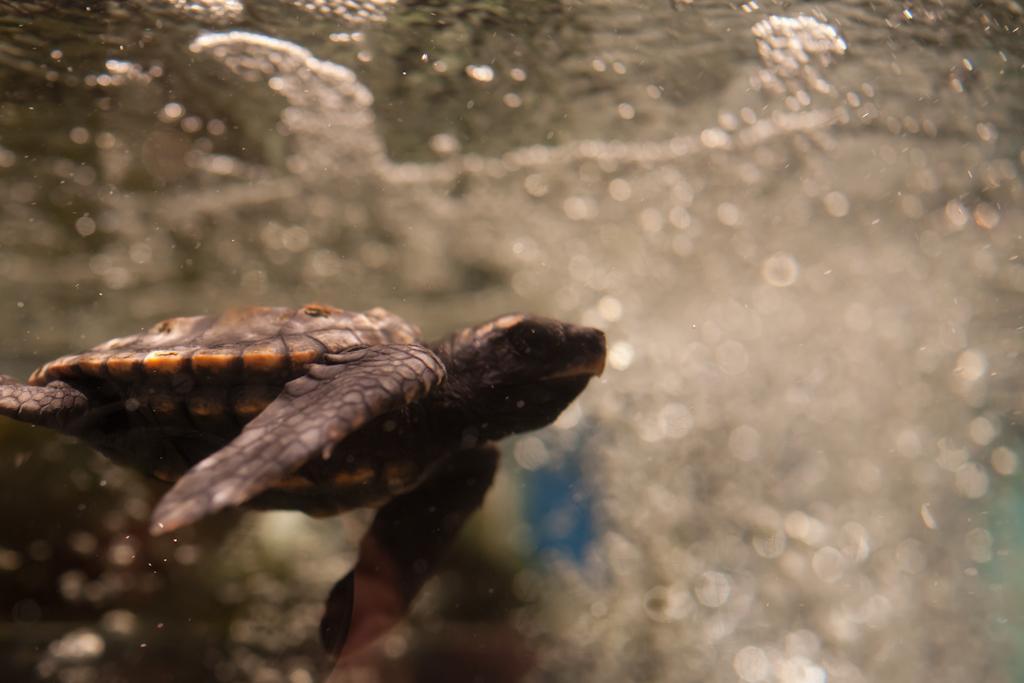Could you give a brief overview of what you see in this image? In this image we can see a turtle in the water. 